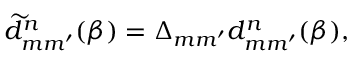<formula> <loc_0><loc_0><loc_500><loc_500>\widetilde { d } _ { m m ^ { \prime } } ^ { n } ( \beta ) = \Delta _ { m m ^ { \prime } } d _ { m m ^ { \prime } } ^ { n } ( \beta ) ,</formula> 